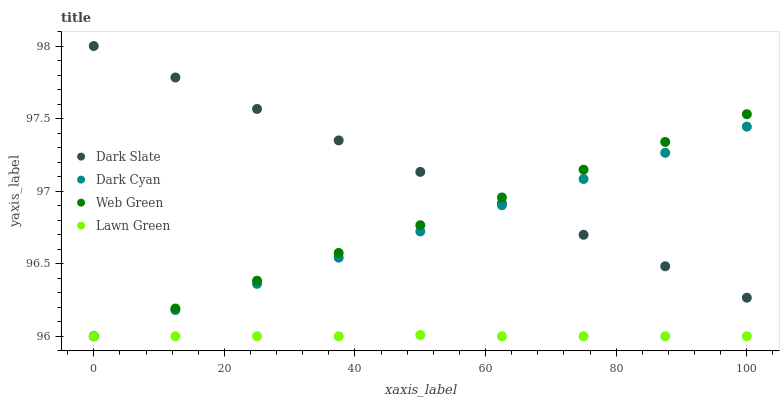Does Lawn Green have the minimum area under the curve?
Answer yes or no. Yes. Does Dark Slate have the maximum area under the curve?
Answer yes or no. Yes. Does Web Green have the minimum area under the curve?
Answer yes or no. No. Does Web Green have the maximum area under the curve?
Answer yes or no. No. Is Web Green the smoothest?
Answer yes or no. Yes. Is Lawn Green the roughest?
Answer yes or no. Yes. Is Dark Slate the smoothest?
Answer yes or no. No. Is Dark Slate the roughest?
Answer yes or no. No. Does Dark Cyan have the lowest value?
Answer yes or no. Yes. Does Dark Slate have the lowest value?
Answer yes or no. No. Does Dark Slate have the highest value?
Answer yes or no. Yes. Does Web Green have the highest value?
Answer yes or no. No. Is Lawn Green less than Dark Slate?
Answer yes or no. Yes. Is Dark Slate greater than Lawn Green?
Answer yes or no. Yes. Does Lawn Green intersect Dark Cyan?
Answer yes or no. Yes. Is Lawn Green less than Dark Cyan?
Answer yes or no. No. Is Lawn Green greater than Dark Cyan?
Answer yes or no. No. Does Lawn Green intersect Dark Slate?
Answer yes or no. No. 